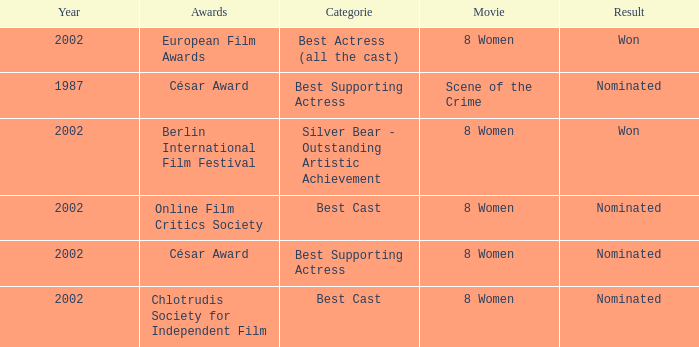In what year was the movie 8 women up for a César Award? 2002.0. 